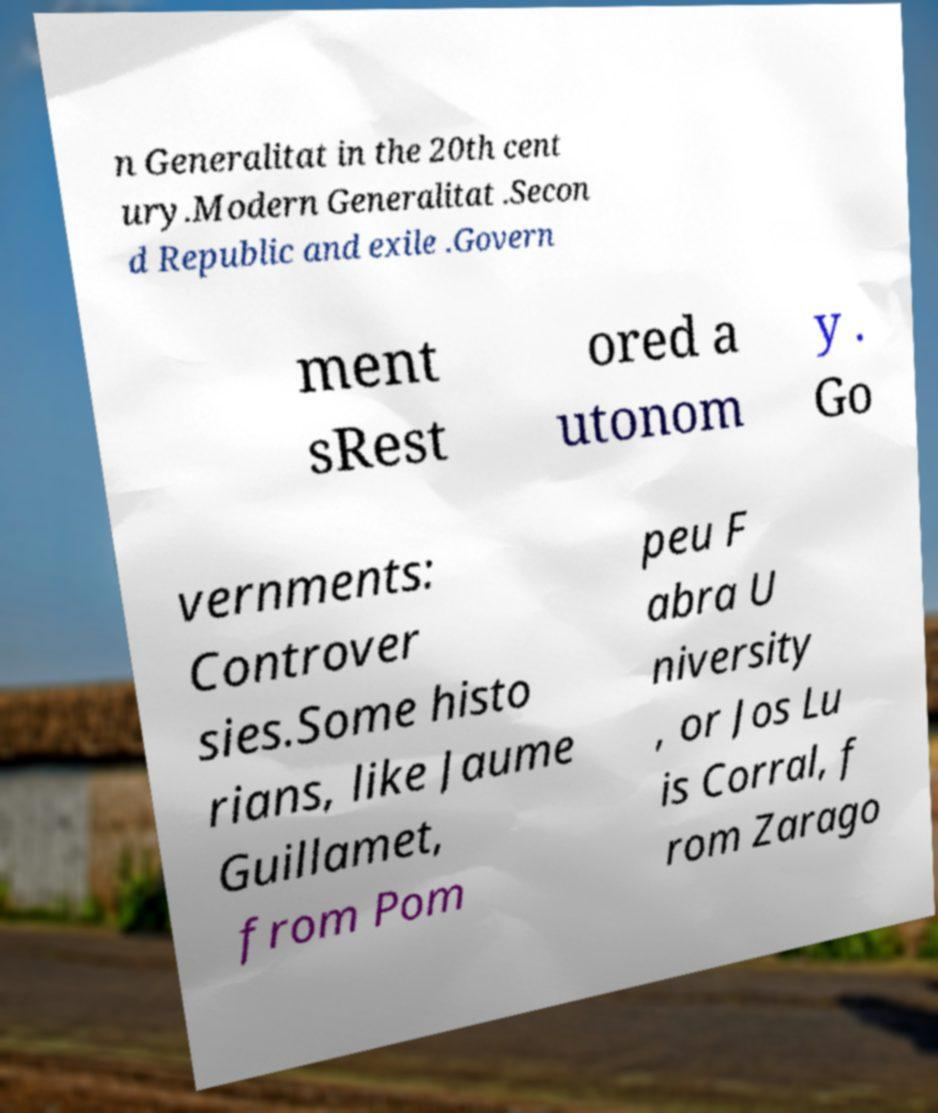There's text embedded in this image that I need extracted. Can you transcribe it verbatim? n Generalitat in the 20th cent ury.Modern Generalitat .Secon d Republic and exile .Govern ment sRest ored a utonom y . Go vernments: Controver sies.Some histo rians, like Jaume Guillamet, from Pom peu F abra U niversity , or Jos Lu is Corral, f rom Zarago 